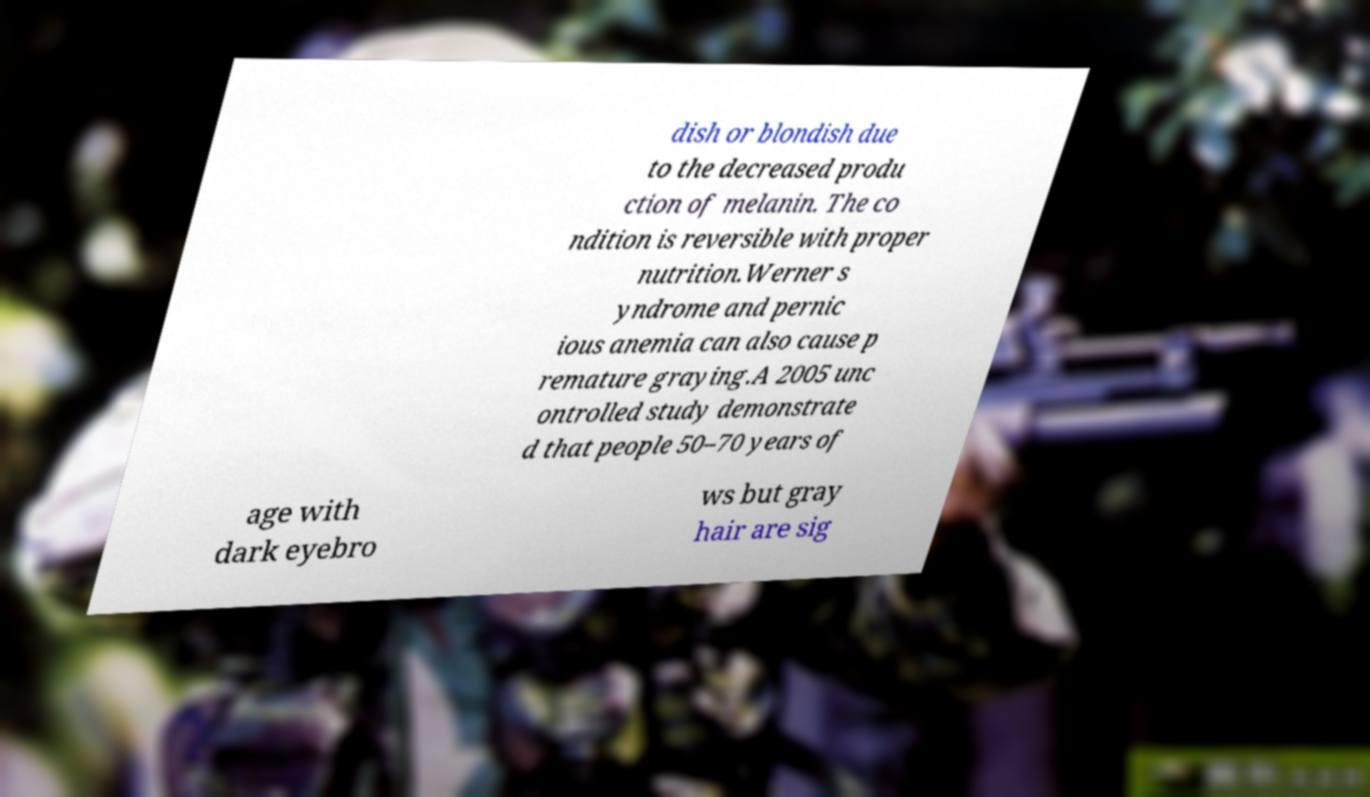There's text embedded in this image that I need extracted. Can you transcribe it verbatim? dish or blondish due to the decreased produ ction of melanin. The co ndition is reversible with proper nutrition.Werner s yndrome and pernic ious anemia can also cause p remature graying.A 2005 unc ontrolled study demonstrate d that people 50–70 years of age with dark eyebro ws but gray hair are sig 